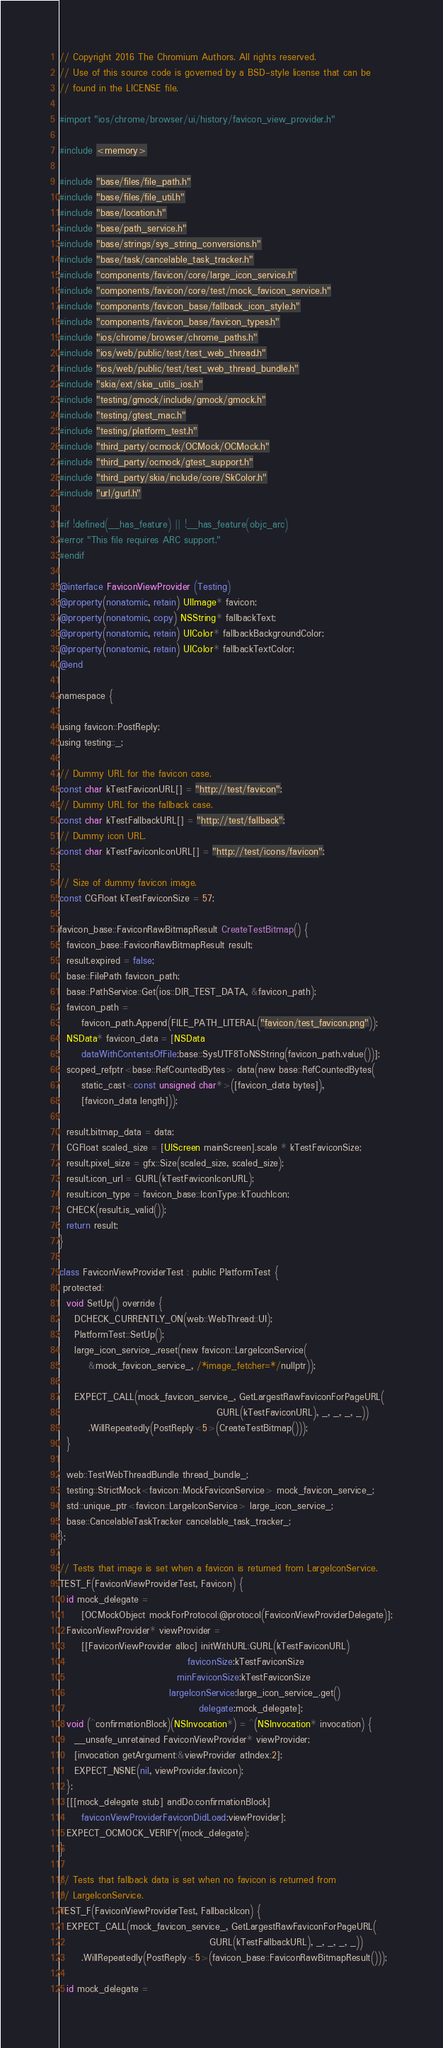Convert code to text. <code><loc_0><loc_0><loc_500><loc_500><_ObjectiveC_>// Copyright 2016 The Chromium Authors. All rights reserved.
// Use of this source code is governed by a BSD-style license that can be
// found in the LICENSE file.

#import "ios/chrome/browser/ui/history/favicon_view_provider.h"

#include <memory>

#include "base/files/file_path.h"
#include "base/files/file_util.h"
#include "base/location.h"
#include "base/path_service.h"
#include "base/strings/sys_string_conversions.h"
#include "base/task/cancelable_task_tracker.h"
#include "components/favicon/core/large_icon_service.h"
#include "components/favicon/core/test/mock_favicon_service.h"
#include "components/favicon_base/fallback_icon_style.h"
#include "components/favicon_base/favicon_types.h"
#include "ios/chrome/browser/chrome_paths.h"
#include "ios/web/public/test/test_web_thread.h"
#include "ios/web/public/test/test_web_thread_bundle.h"
#include "skia/ext/skia_utils_ios.h"
#include "testing/gmock/include/gmock/gmock.h"
#include "testing/gtest_mac.h"
#include "testing/platform_test.h"
#include "third_party/ocmock/OCMock/OCMock.h"
#include "third_party/ocmock/gtest_support.h"
#include "third_party/skia/include/core/SkColor.h"
#include "url/gurl.h"

#if !defined(__has_feature) || !__has_feature(objc_arc)
#error "This file requires ARC support."
#endif

@interface FaviconViewProvider (Testing)
@property(nonatomic, retain) UIImage* favicon;
@property(nonatomic, copy) NSString* fallbackText;
@property(nonatomic, retain) UIColor* fallbackBackgroundColor;
@property(nonatomic, retain) UIColor* fallbackTextColor;
@end

namespace {

using favicon::PostReply;
using testing::_;

// Dummy URL for the favicon case.
const char kTestFaviconURL[] = "http://test/favicon";
// Dummy URL for the fallback case.
const char kTestFallbackURL[] = "http://test/fallback";
// Dummy icon URL.
const char kTestFaviconIconURL[] = "http://test/icons/favicon";

// Size of dummy favicon image.
const CGFloat kTestFaviconSize = 57;

favicon_base::FaviconRawBitmapResult CreateTestBitmap() {
  favicon_base::FaviconRawBitmapResult result;
  result.expired = false;
  base::FilePath favicon_path;
  base::PathService::Get(ios::DIR_TEST_DATA, &favicon_path);
  favicon_path =
      favicon_path.Append(FILE_PATH_LITERAL("favicon/test_favicon.png"));
  NSData* favicon_data = [NSData
      dataWithContentsOfFile:base::SysUTF8ToNSString(favicon_path.value())];
  scoped_refptr<base::RefCountedBytes> data(new base::RefCountedBytes(
      static_cast<const unsigned char*>([favicon_data bytes]),
      [favicon_data length]));

  result.bitmap_data = data;
  CGFloat scaled_size = [UIScreen mainScreen].scale * kTestFaviconSize;
  result.pixel_size = gfx::Size(scaled_size, scaled_size);
  result.icon_url = GURL(kTestFaviconIconURL);
  result.icon_type = favicon_base::IconType::kTouchIcon;
  CHECK(result.is_valid());
  return result;
}

class FaviconViewProviderTest : public PlatformTest {
 protected:
  void SetUp() override {
    DCHECK_CURRENTLY_ON(web::WebThread::UI);
    PlatformTest::SetUp();
    large_icon_service_.reset(new favicon::LargeIconService(
        &mock_favicon_service_, /*image_fetcher=*/nullptr));

    EXPECT_CALL(mock_favicon_service_, GetLargestRawFaviconForPageURL(
                                           GURL(kTestFaviconURL), _, _, _, _))
        .WillRepeatedly(PostReply<5>(CreateTestBitmap()));
  }

  web::TestWebThreadBundle thread_bundle_;
  testing::StrictMock<favicon::MockFaviconService> mock_favicon_service_;
  std::unique_ptr<favicon::LargeIconService> large_icon_service_;
  base::CancelableTaskTracker cancelable_task_tracker_;
};

// Tests that image is set when a favicon is returned from LargeIconService.
TEST_F(FaviconViewProviderTest, Favicon) {
  id mock_delegate =
      [OCMockObject mockForProtocol:@protocol(FaviconViewProviderDelegate)];
  FaviconViewProvider* viewProvider =
      [[FaviconViewProvider alloc] initWithURL:GURL(kTestFaviconURL)
                                   faviconSize:kTestFaviconSize
                                minFaviconSize:kTestFaviconSize
                              largeIconService:large_icon_service_.get()
                                      delegate:mock_delegate];
  void (^confirmationBlock)(NSInvocation*) = ^(NSInvocation* invocation) {
    __unsafe_unretained FaviconViewProvider* viewProvider;
    [invocation getArgument:&viewProvider atIndex:2];
    EXPECT_NSNE(nil, viewProvider.favicon);
  };
  [[[mock_delegate stub] andDo:confirmationBlock]
      faviconViewProviderFaviconDidLoad:viewProvider];
  EXPECT_OCMOCK_VERIFY(mock_delegate);
}

// Tests that fallback data is set when no favicon is returned from
// LargeIconService.
TEST_F(FaviconViewProviderTest, FallbackIcon) {
  EXPECT_CALL(mock_favicon_service_, GetLargestRawFaviconForPageURL(
                                         GURL(kTestFallbackURL), _, _, _, _))
      .WillRepeatedly(PostReply<5>(favicon_base::FaviconRawBitmapResult()));

  id mock_delegate =</code> 